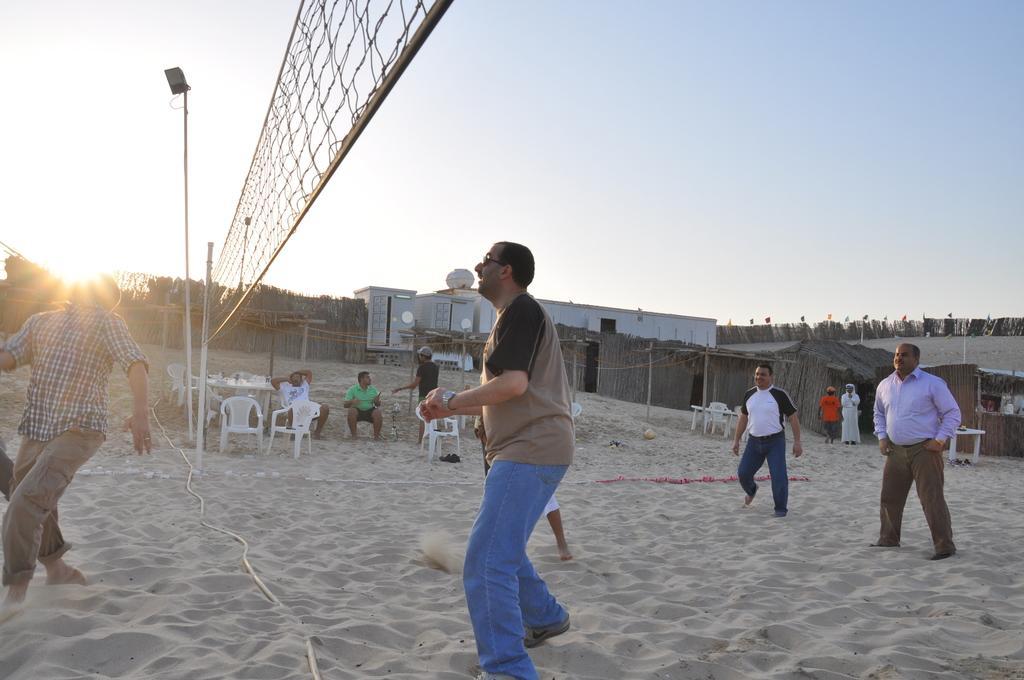Could you give a brief overview of what you see in this image? In this picture, we see six men are playing game. In between them, we see a net and beside that, we see a street light. At the bottom of the picture, we see sand. Behind them, we see tables and chairs. We see two men are sitting on the chairs. On the right side, we see the huts and buildings in white color. There are trees and flags in the background. On the left side, we see trees and the sun. At the top of the picture, we see the sky. 